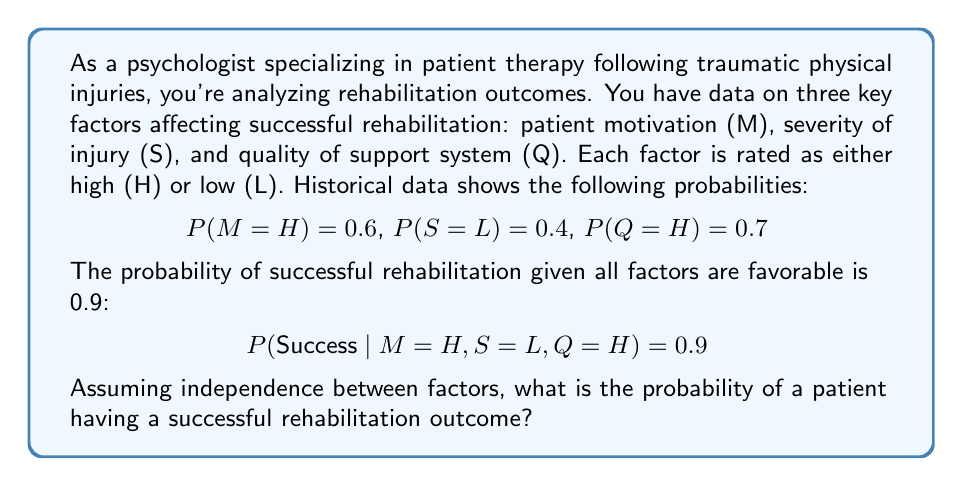Provide a solution to this math problem. To solve this problem, we'll use the law of total probability and the given information. Let's break it down step-by-step:

1) First, we need to calculate the probability of all favorable factors occurring together:

   $$P(M=H, S=L, Q=H) = P(M=H) \times P(S=L) \times P(Q=H)$$
   $$= 0.6 \times 0.4 \times 0.7 = 0.168$$

2) Now, we can calculate the probability of success given all favorable factors:

   $$P(Success \cap M=H \cap S=L \cap Q=H) = P(Success | M=H, S=L, Q=H) \times P(M=H, S=L, Q=H)$$
   $$= 0.9 \times 0.168 = 0.1512$$

3) To find the total probability of success, we would need to sum the probabilities of success for all possible combinations of factors. However, we don't have this information for other combinations.

4) We can establish a lower bound for the probability of success, which is the probability we calculated in step 2. This represents the probability of success when all factors are favorable.

5) Therefore, the probability of a successful rehabilitation outcome is at least 0.1512 or 15.12%.

Note: This is a lower bound because there's still a possibility of success when not all factors are favorable, but we don't have that information.
Answer: $\geq 0.1512$ or $\geq 15.12\%$ 